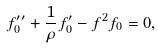Convert formula to latex. <formula><loc_0><loc_0><loc_500><loc_500>f _ { 0 } ^ { \prime \prime } + \frac { 1 } { \rho } f _ { 0 } ^ { \prime } - f ^ { 2 } f _ { 0 } = 0 ,</formula> 